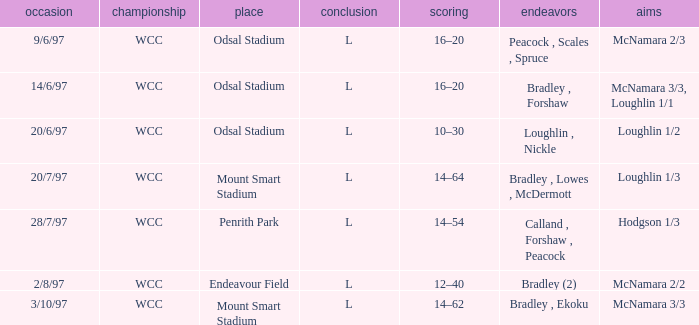Can you parse all the data within this table? {'header': ['occasion', 'championship', 'place', 'conclusion', 'scoring', 'endeavors', 'aims'], 'rows': [['9/6/97', 'WCC', 'Odsal Stadium', 'L', '16–20', 'Peacock , Scales , Spruce', 'McNamara 2/3'], ['14/6/97', 'WCC', 'Odsal Stadium', 'L', '16–20', 'Bradley , Forshaw', 'McNamara 3/3, Loughlin 1/1'], ['20/6/97', 'WCC', 'Odsal Stadium', 'L', '10–30', 'Loughlin , Nickle', 'Loughlin 1/2'], ['20/7/97', 'WCC', 'Mount Smart Stadium', 'L', '14–64', 'Bradley , Lowes , McDermott', 'Loughlin 1/3'], ['28/7/97', 'WCC', 'Penrith Park', 'L', '14–54', 'Calland , Forshaw , Peacock', 'Hodgson 1/3'], ['2/8/97', 'WCC', 'Endeavour Field', 'L', '12–40', 'Bradley (2)', 'McNamara 2/2'], ['3/10/97', 'WCC', 'Mount Smart Stadium', 'L', '14–62', 'Bradley , Ekoku', 'McNamara 3/3']]} What were the endeavors undertaken on 6/14/97? Bradley , Forshaw. 